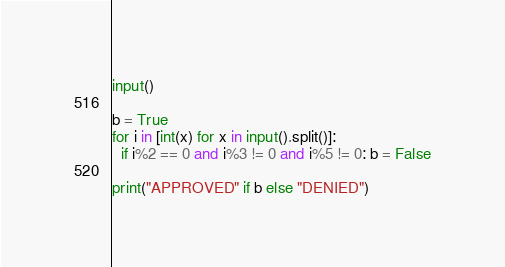Convert code to text. <code><loc_0><loc_0><loc_500><loc_500><_Python_>input()

b = True
for i in [int(x) for x in input().split()]:
  if i%2 == 0 and i%3 != 0 and i%5 != 0: b = False

print("APPROVED" if b else "DENIED")</code> 